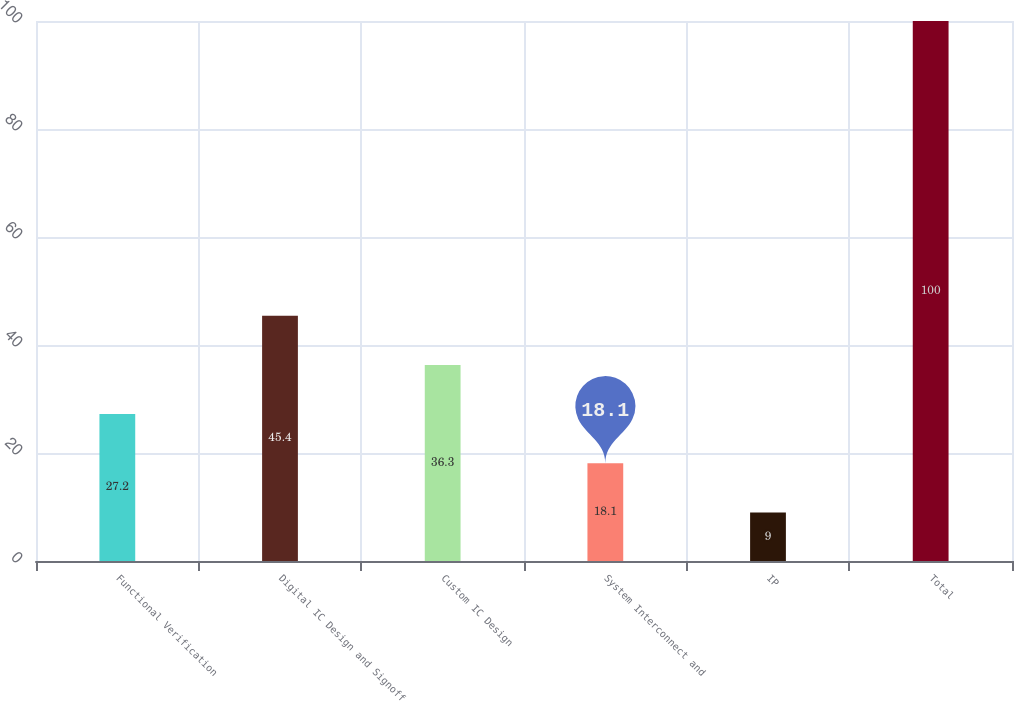<chart> <loc_0><loc_0><loc_500><loc_500><bar_chart><fcel>Functional Verification<fcel>Digital IC Design and Signoff<fcel>Custom IC Design<fcel>System Interconnect and<fcel>IP<fcel>Total<nl><fcel>27.2<fcel>45.4<fcel>36.3<fcel>18.1<fcel>9<fcel>100<nl></chart> 